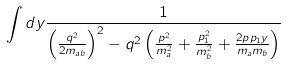<formula> <loc_0><loc_0><loc_500><loc_500>\int d y \frac { 1 } { \left ( \frac { q ^ { 2 } } { 2 m _ { a b } } \right ) ^ { 2 } - q ^ { 2 } \left ( \frac { p ^ { 2 } } { m _ { a } ^ { 2 } } + \frac { p _ { 1 } ^ { 2 } } { m _ { b } ^ { 2 } } + \frac { 2 p p _ { 1 } y } { m _ { a } m _ { b } } \right ) }</formula> 